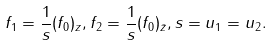<formula> <loc_0><loc_0><loc_500><loc_500>f _ { 1 } = \frac { 1 } { s } ( f _ { 0 } ) _ { z } , f _ { 2 } = \frac { 1 } { s } ( f _ { 0 } ) _ { \bar { z } } , s = u _ { 1 } = u _ { 2 } .</formula> 